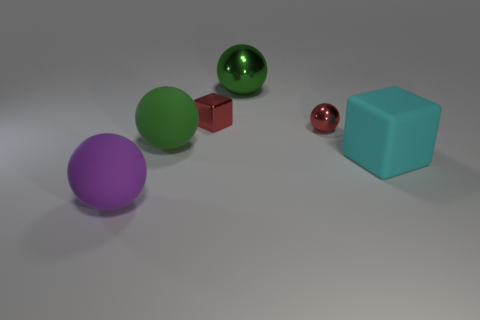How many things are either large rubber spheres to the right of the purple rubber thing or big green balls in front of the tiny red metallic block?
Give a very brief answer. 1. Are there any rubber blocks right of the cyan thing?
Your answer should be compact. No. There is a big ball behind the big rubber sphere that is to the right of the purple thing left of the tiny sphere; what color is it?
Your response must be concise. Green. Is the large shiny object the same shape as the large purple matte object?
Make the answer very short. Yes. What color is the large sphere that is the same material as the red cube?
Your answer should be compact. Green. What number of things are either large rubber objects behind the cyan thing or small red metal balls?
Give a very brief answer. 2. What is the size of the red shiny thing in front of the red cube?
Provide a short and direct response. Small. There is a purple object; is its size the same as the rubber ball to the right of the large purple ball?
Your answer should be compact. Yes. There is a metal ball on the left side of the tiny metallic object that is in front of the tiny red metal cube; what is its color?
Your response must be concise. Green. How many other objects are the same color as the tiny metal cube?
Offer a terse response. 1. 